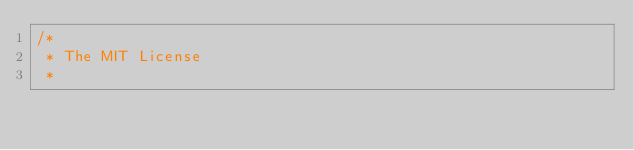Convert code to text. <code><loc_0><loc_0><loc_500><loc_500><_Java_>/*
 * The MIT License
 * </code> 